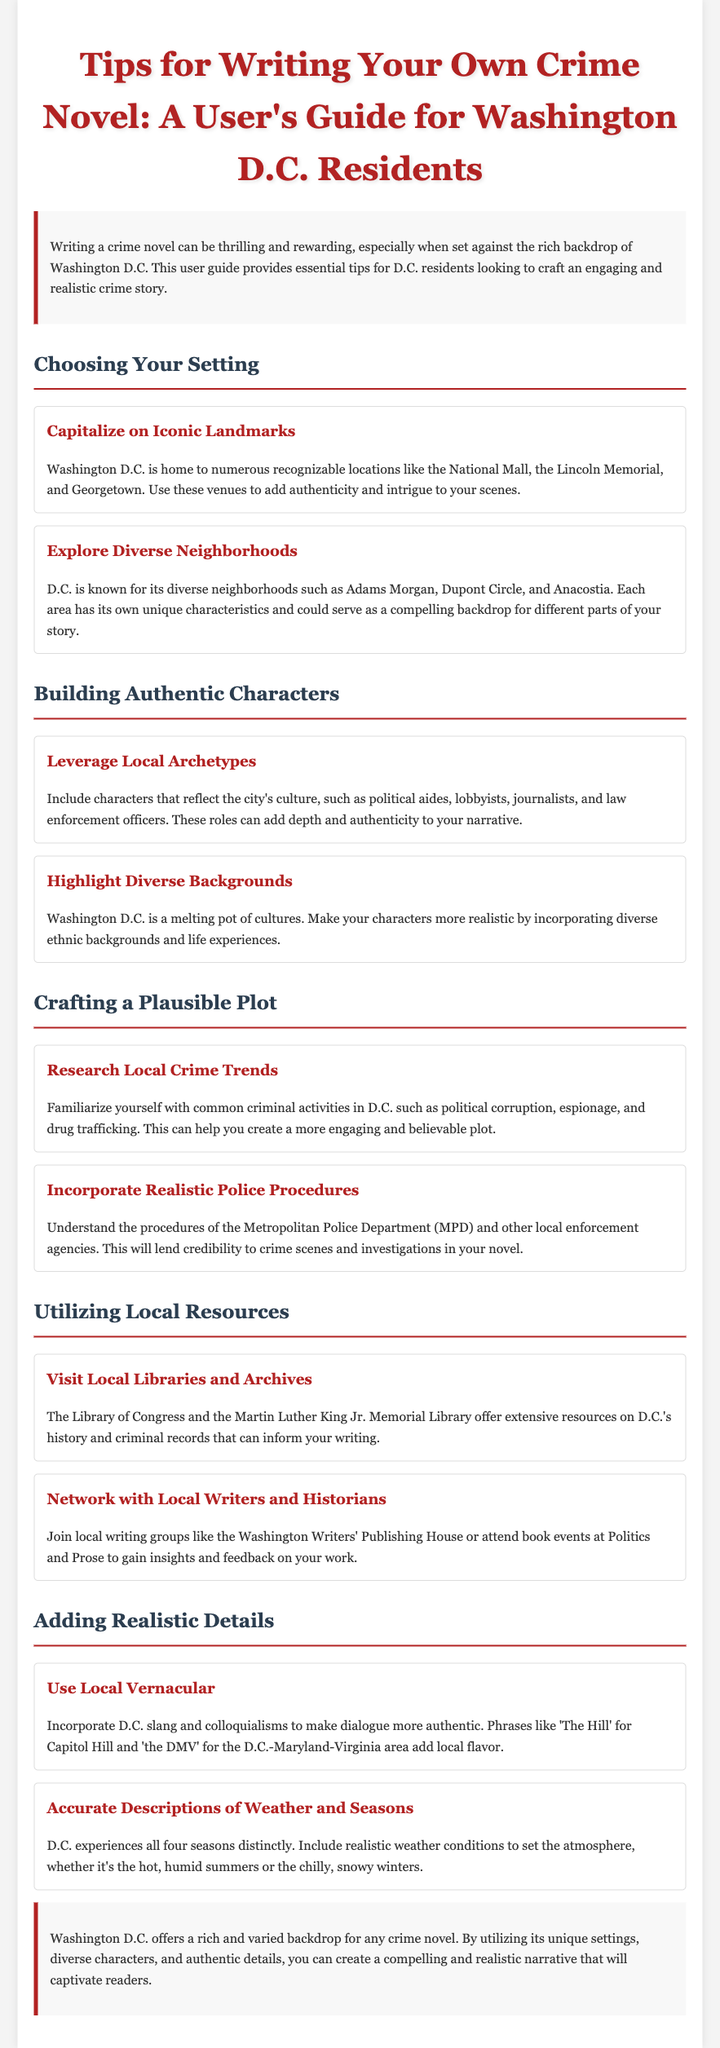what is the title of the user guide? The title is prominently displayed at the top of the document and states the purpose of the guide for local residents.
Answer: Tips for Writing Your Own Crime Novel: A User's Guide for Washington D.C. Residents what should you research to craft a plausible plot? The document advises familiarizing oneself with specific types of crime prevalent in the area.
Answer: Local crime trends how many sections are there in the document? The document is organized into several main sections that provide tips for writing a crime novel.
Answer: Five which iconic landmark is mentioned for authenticity? The guide suggests a well-known location in D.C. that can be used in scenes to add realism.
Answer: National Mall what type of characters should be included for authenticity? The guide recommends certain roles that reflect local culture to enhance the narrative depth.
Answer: Political aides what local resource is suggested for writers? The document mentions a significant library in D.C. that offers extensive historical and criminal records.
Answer: Library of Congress how can local vernacular enhance dialogue? The document explains using specific local language to make interactions more genuine and relatable.
Answer: Authenticity what is one of the diverse neighborhoods mentioned? The guide lists neighborhoods that could serve as unique backdrops in a crime novel.
Answer: Adams Morgan 